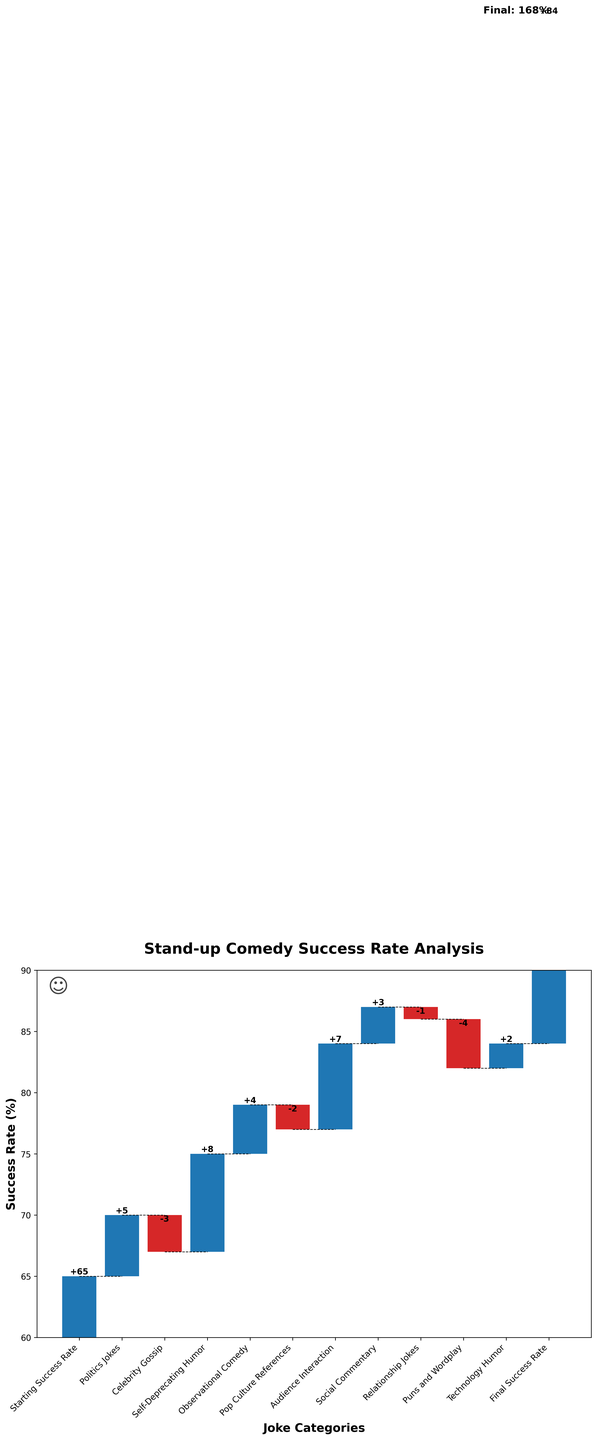What is the starting success rate shown in the figure? The starting success rate is visible at the first bar of the waterfall chart.
Answer: 65% How many joke categories are presented in the chart? Count the bars in the waterfall chart from "Politics Jokes" to "Technology Humor."
Answer: 10 Which joke category had the largest positive impact on the success rate? Identify the bar with the highest positive value. "Self-Deprecating Humor" shows the largest positive impact with a value of +8.
Answer: Self-Deprecating Humor Which joke category had the largest negative impact on the success rate? Identify the bar with the highest negative value. "Puns and Wordplay" shows the largest negative impact with a value of -4.
Answer: Puns and Wordplay What is the final success rate? This is indicated as the last cumulative value at the end of the chart.
Answer: 84% What is the combined impact of "Politics Jokes" and "Audience Interaction"? Add the impact values of both categories: 5 (Politics Jokes) + 7 (Audience Interaction).
Answer: 12 How does the success rate change after the "Pop Culture References" category? The success rate after adding "Pop Culture References" is 77 (cumulative) - 2 (value of the category) = 75.
Answer: It decreases to 75% Which category had the smallest impact on the success rate? Identify the bar with the smallest absolute value, which in this case is "Relationship Jokes" with -1.
Answer: Relationship Jokes How many categories resulted in a negative impact on the success rate? Count the bars with negative values. There are four categories: "Celebrity Gossip," "Pop Culture References," "Relationship Jokes," and "Puns and Wordplay."
Answer: 4 Between "Observational Comedy" and "Technology Humor," which had a greater impact on the success rate? Compare the values of both categories. "Observational Comedy" has a value of 4, and "Technology Humor" has a value of 2, so "Observational Comedy" had a greater impact.
Answer: Observational Comedy 